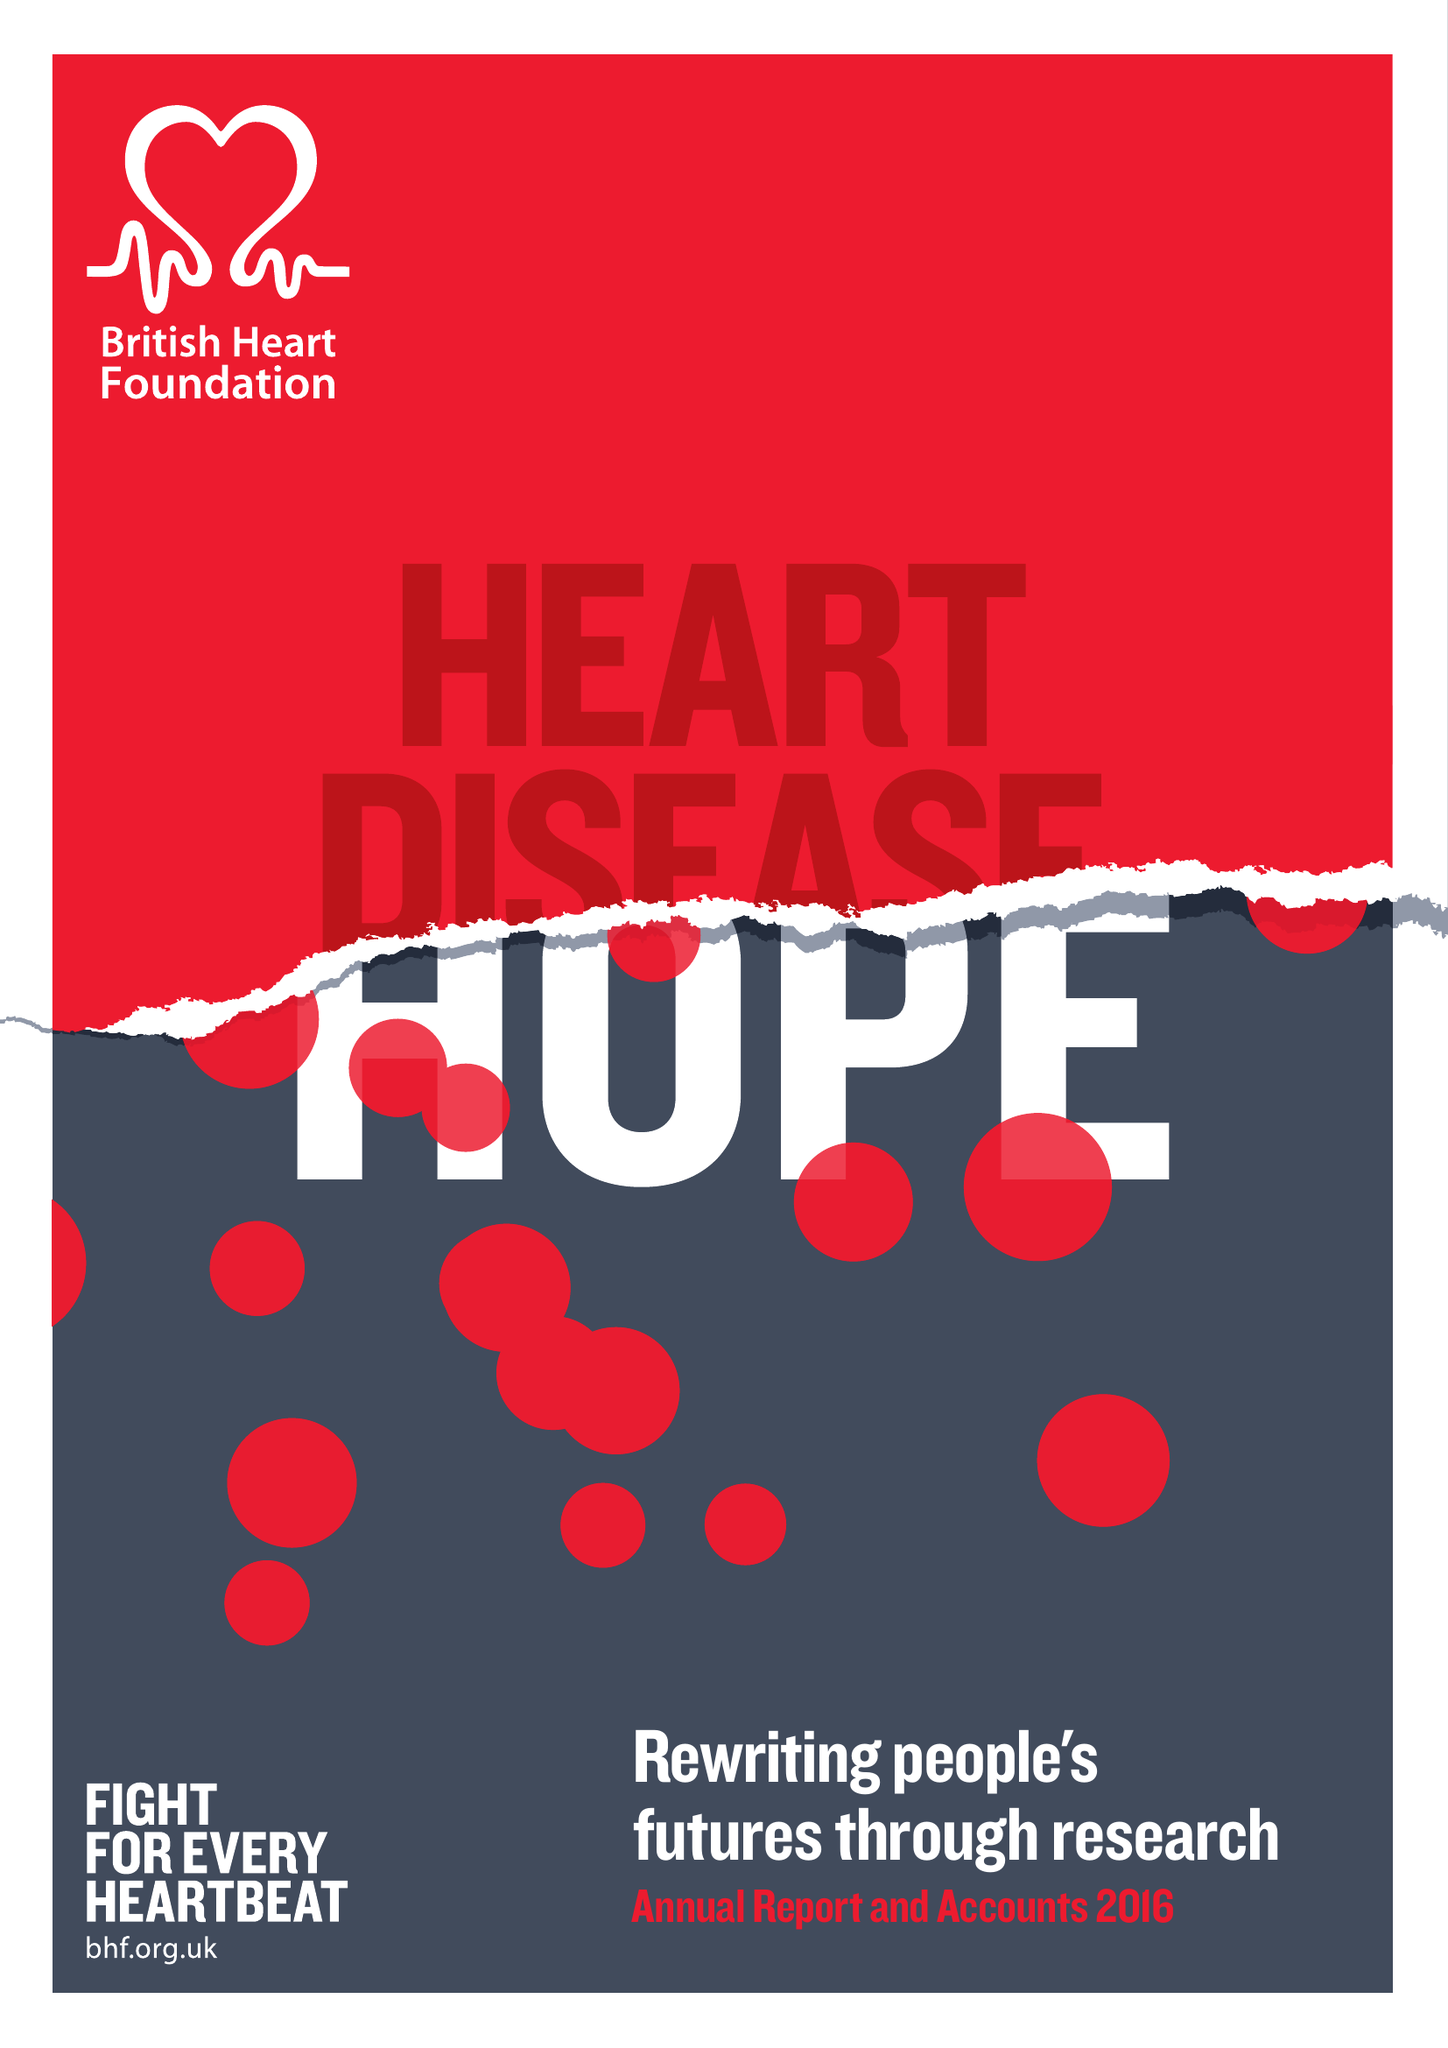What is the value for the address__postcode?
Answer the question using a single word or phrase. NW1 7AW 